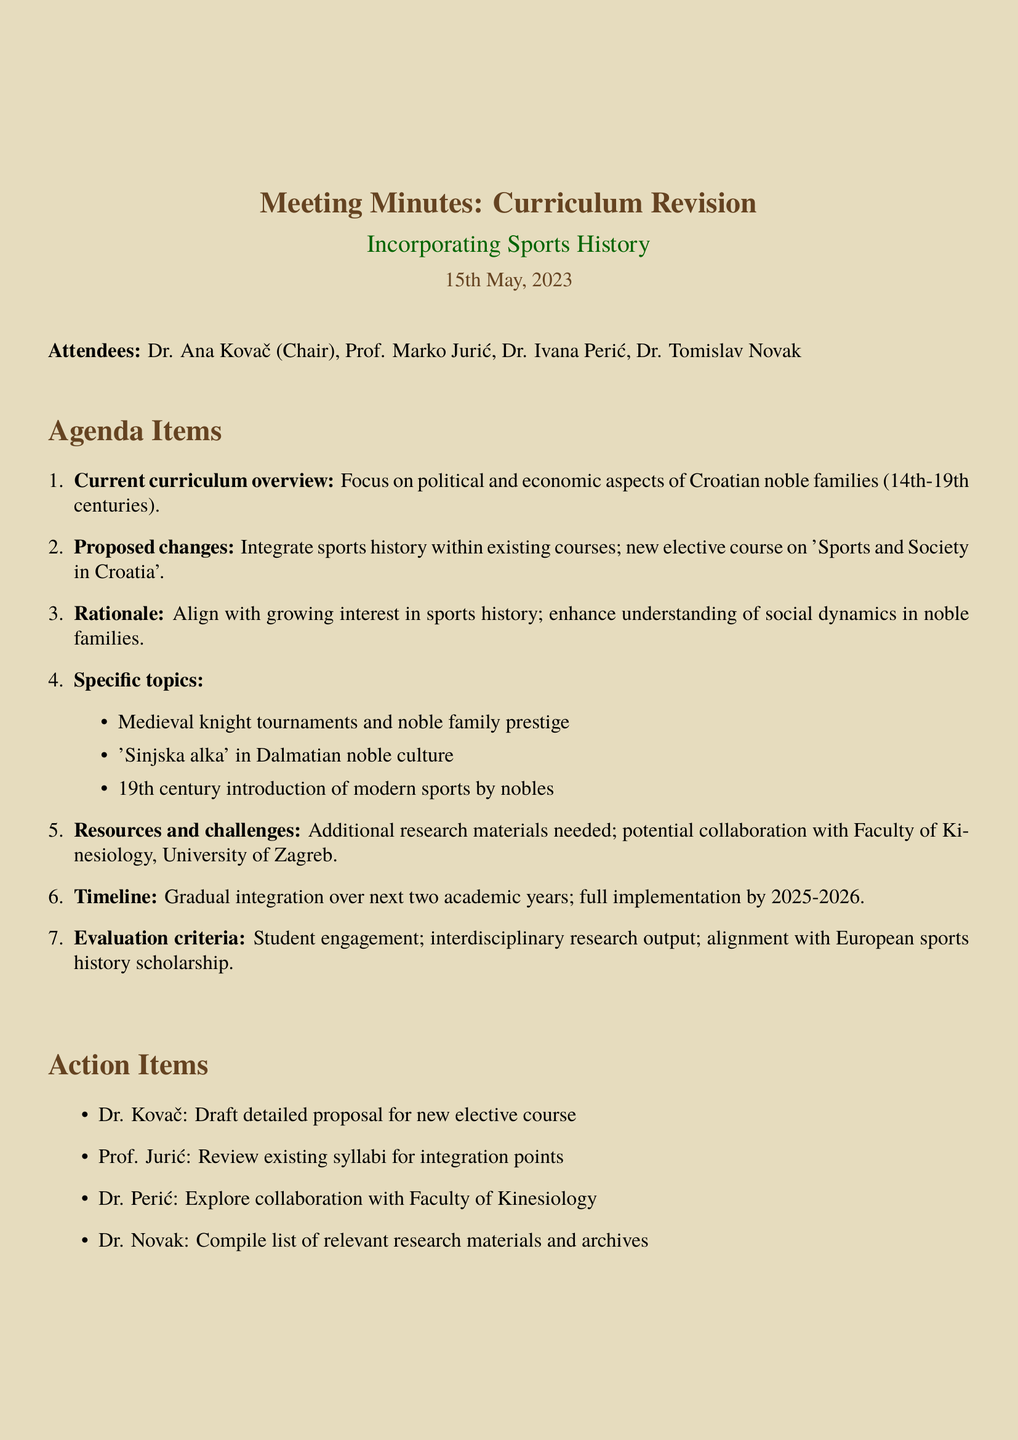what is the date of the meeting? The date of the meeting is mentioned in the document under the title section.
Answer: 15th May, 2023 who chaired the meeting? The chairperson of the meeting is listed among the attendees.
Answer: Dr. Ana Kovač what is the proposed new elective course title? The title of the proposed new elective course is noted in the agenda items.
Answer: Sports and Society in Croatia what is the timeline for full implementation of the proposed changes? The timeline is specified in the document, indicating when the changes will be fully implemented.
Answer: 2025-2026 which noble family member was mentioned in relation to modern sports? The specific noble family member mentioned in the context of sports is included in the specific topics section.
Answer: Count Josip Drašković what is one rationale for the proposed changes to the curriculum? The rationale can be found in the agenda items, providing reasons for the proposed curriculum change.
Answer: Align with growing interest in sports history what resource is identified as a potential challenge? The document mentions specific challenges related to resources in the context of the proposed changes.
Answer: Additional research materials who is responsible for drafting the proposal for the new course? The action items section specifies responsibilities assigned to attendees.
Answer: Dr. Kovač 